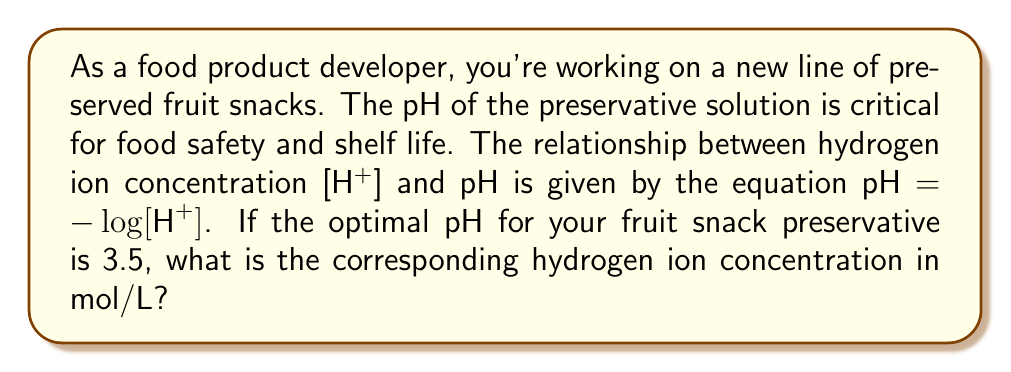Help me with this question. Let's approach this step-by-step:

1) We are given the equation relating pH and hydrogen ion concentration:

   $\text{pH} = -\log[\text{H}^+]$

2) We know the optimal pH is 3.5, so we can substitute this into our equation:

   $3.5 = -\log[\text{H}^+]$

3) To solve for [H+], we need to "undo" the logarithm. We can do this by raising both sides as a power of 10:

   $10^{-3.5} = 10^{-\log[\text{H}^+]}$

4) The right side simplifies due to the logarithm rule $10^{\log x} = x$:

   $10^{-3.5} = [\text{H}^+]$

5) Now we just need to calculate $10^{-3.5}$:

   $[\text{H}^+] = 10^{-3.5} \approx 3.162 \times 10^{-4}$ mol/L

Therefore, the hydrogen ion concentration is approximately $3.162 \times 10^{-4}$ mol/L.
Answer: $3.162 \times 10^{-4}$ mol/L 